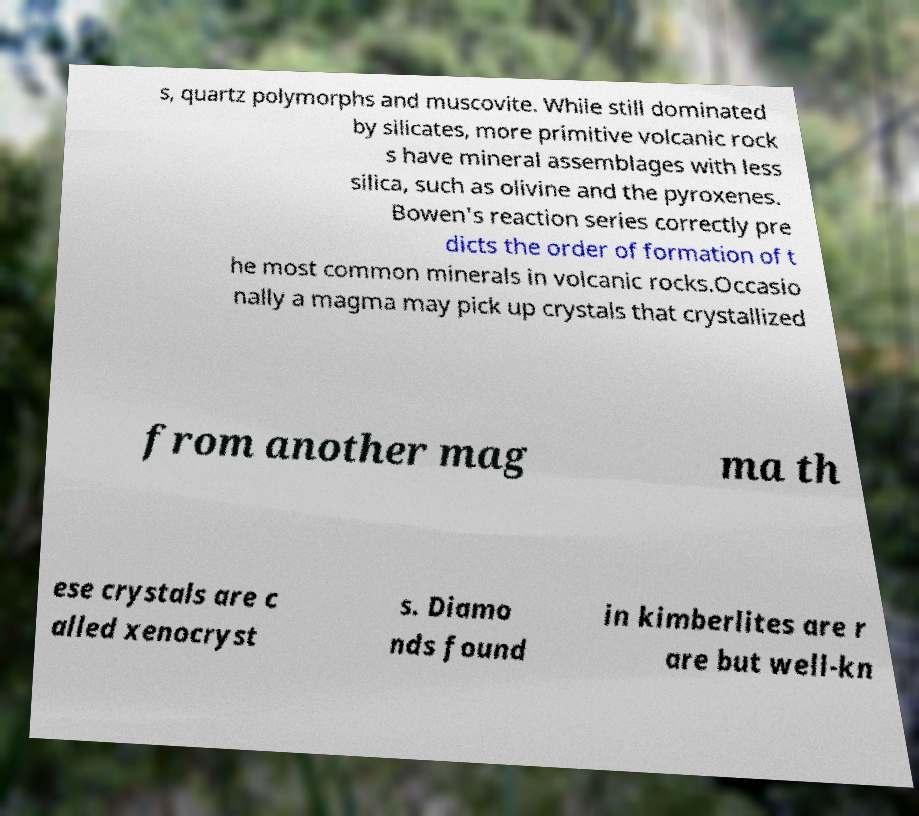There's text embedded in this image that I need extracted. Can you transcribe it verbatim? s, quartz polymorphs and muscovite. While still dominated by silicates, more primitive volcanic rock s have mineral assemblages with less silica, such as olivine and the pyroxenes. Bowen's reaction series correctly pre dicts the order of formation of t he most common minerals in volcanic rocks.Occasio nally a magma may pick up crystals that crystallized from another mag ma th ese crystals are c alled xenocryst s. Diamo nds found in kimberlites are r are but well-kn 